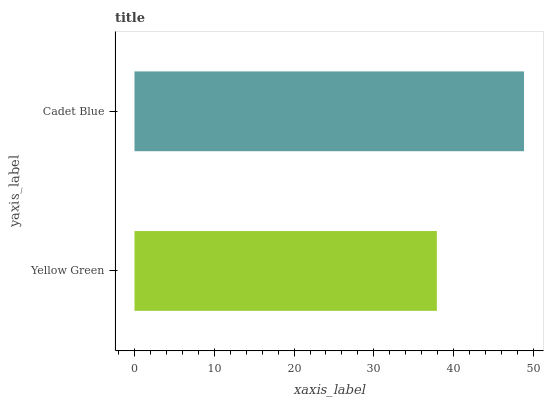Is Yellow Green the minimum?
Answer yes or no. Yes. Is Cadet Blue the maximum?
Answer yes or no. Yes. Is Cadet Blue the minimum?
Answer yes or no. No. Is Cadet Blue greater than Yellow Green?
Answer yes or no. Yes. Is Yellow Green less than Cadet Blue?
Answer yes or no. Yes. Is Yellow Green greater than Cadet Blue?
Answer yes or no. No. Is Cadet Blue less than Yellow Green?
Answer yes or no. No. Is Cadet Blue the high median?
Answer yes or no. Yes. Is Yellow Green the low median?
Answer yes or no. Yes. Is Yellow Green the high median?
Answer yes or no. No. Is Cadet Blue the low median?
Answer yes or no. No. 